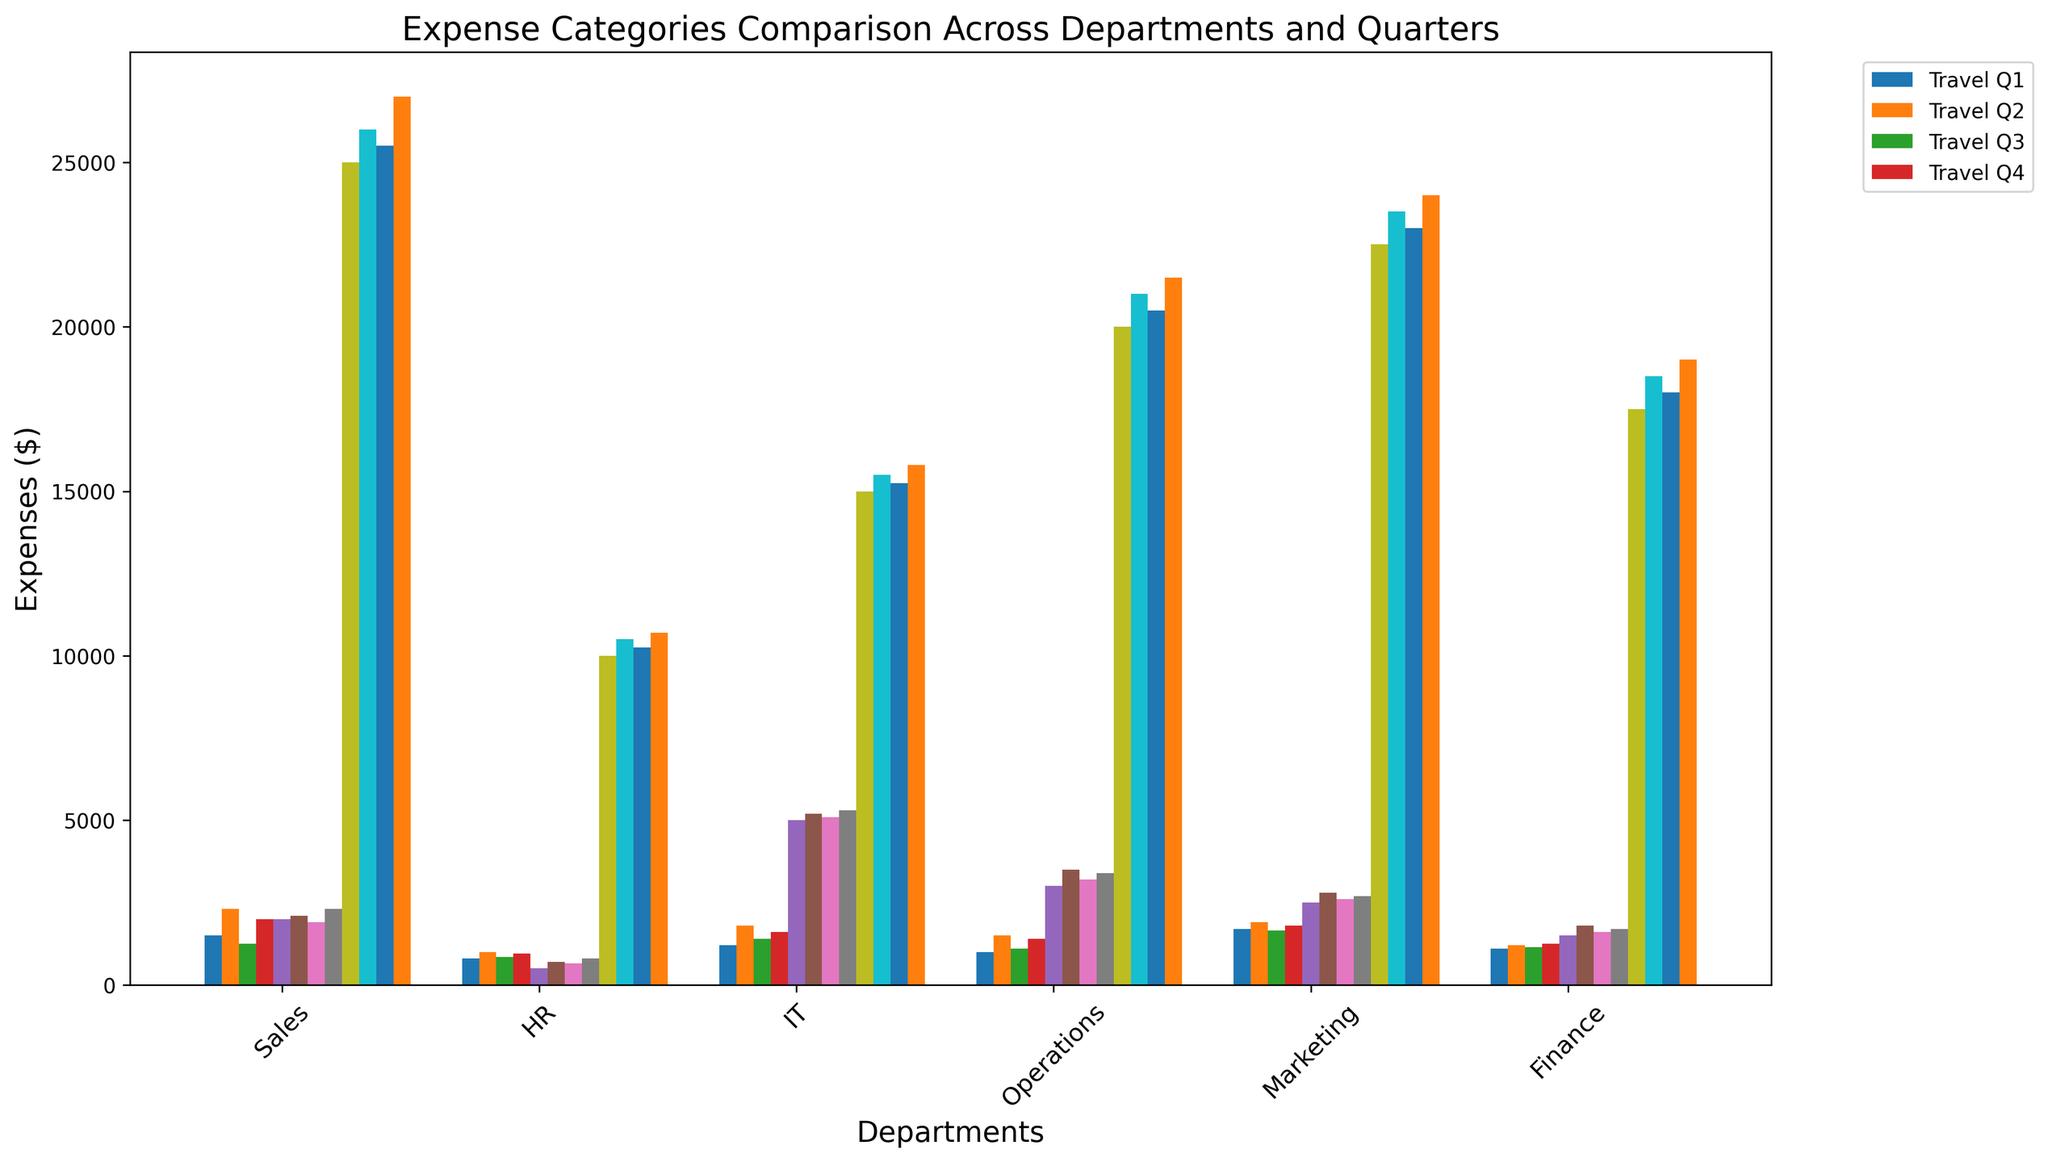What's the difference in travel expenses between Marketing and HR in Q2? To find the difference in travel expenses, check the height of the bars labeled "Travel Q2" for both Marketing and HR. Marketing's travel expense in Q2 is $1900, whereas HR's is $1000. Subtract HR's expense from Marketing's expense: $1900 - $1000 = $900.
Answer: $900 Which department had the highest equipment expenses in Q4? To determine the department with the highest equipment expenses in Q4, compare the heights of the "Equipment Q4" bars for each department. The bars indicate that Sales had $2300, HR had $800, IT had $5300, Operations had $3400, Marketing had $2700, and Finance had $1700. IT has the highest equipment expense in Q4 at $5300.
Answer: IT What were the total salaries for the Sales department across all quarters? To find the total salaries for the Sales department, sum the heights of the "Salaries" bar for each quarter in the Sales department. The values are $25000 (Q1), $26000 (Q2), $25500 (Q3), and $27000 (Q4). Add these up: $25000 + $26000 + $25500 + $27000 = $103500.
Answer: $103500 Compare the travel expenses in Q3 between Sales and IT. Which department spent more and by how much? Compare the "Travel Q3" bars of Sales and IT. The Sales department's travel expense in Q3 is $1250 and IT's is $1400. Use the formula: amount spent by IT - amount spent by Sales = $1400 - $1250 = $150.
Answer: IT by $150 What is the average equipment expense for the Operations department across all quarters? To determine the average, sum the equipment expenses for Operations for each quarter and divide by the number of quarters (4). Operations' equipment expenses are $3000 (Q1), $3500 (Q2), $3200 (Q3), and $3400 (Q4). Add them: $3000 + $3500 + $3200 + $3400 = $13100. Divide by 4: $13100 / 4 = $3275.
Answer: $3275 Which department had the smallest travel expense in Q1? Compare the heights of the "Travel Q1" bars for each department. The values are Sales ($1500), HR ($800), IT ($1200), Operations ($1000), Marketing ($1700), and Finance ($1100). HR has the smallest travel expense in Q1 at $800.
Answer: HR What is the combined total equipment expense for Finance in Q2 and Q4? To find the combined total, sum the equipment expenses for Finance in Q2 and Q4. The values are $1800 (Q2) and $1700 (Q4). Add them: $1800 + $1700 = $3500.
Answer: $3500 